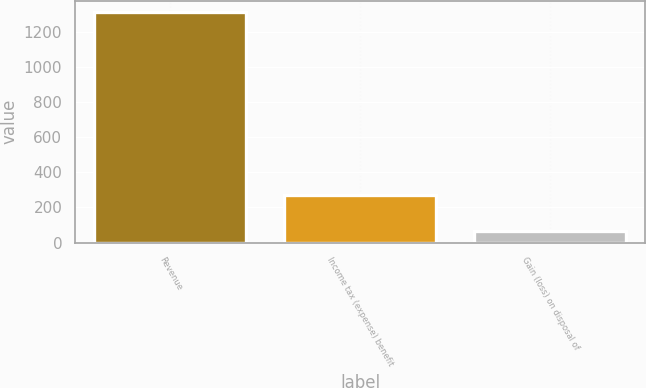<chart> <loc_0><loc_0><loc_500><loc_500><bar_chart><fcel>Revenue<fcel>Income tax (expense) benefit<fcel>Gain (loss) on disposal of<nl><fcel>1310<fcel>270<fcel>64<nl></chart> 